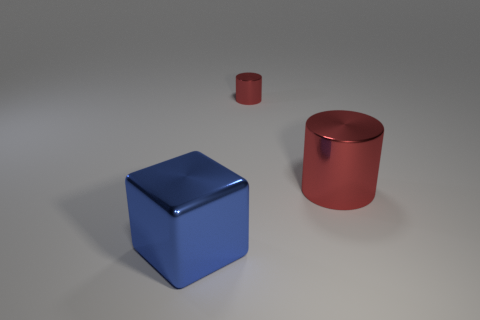Add 3 metal cubes. How many objects exist? 6 Subtract all cylinders. How many objects are left? 1 Add 3 blue blocks. How many blue blocks exist? 4 Subtract 0 brown spheres. How many objects are left? 3 Subtract all gray matte objects. Subtract all large red cylinders. How many objects are left? 2 Add 2 big things. How many big things are left? 4 